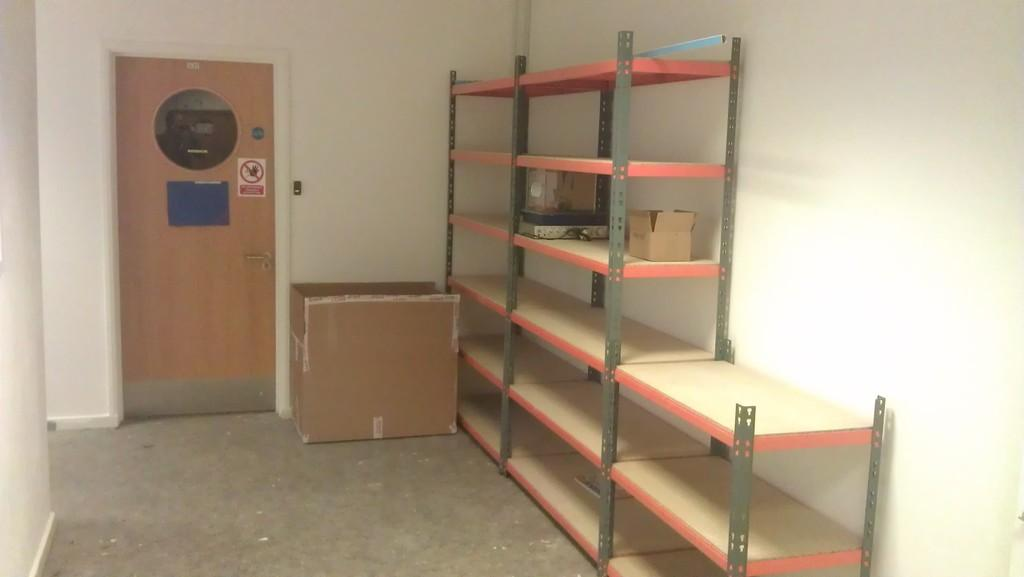What can be seen in the image that is used for holding items? There is a rack in the image that is used for holding items. What type of objects are placed on the rack? There are objects placed on the rack, but the specific objects are not mentioned in the facts. What is the material of the box in the image? The box in the image is made of cardboard. What can be seen in the background of the image? There is a wall and a closed door in the background of the image. What type of corn is being grown in the image? There is no corn present in the image. What attraction can be seen in the background of the image? There is no attraction mentioned in the image; only a wall and a closed door are visible in the background. 